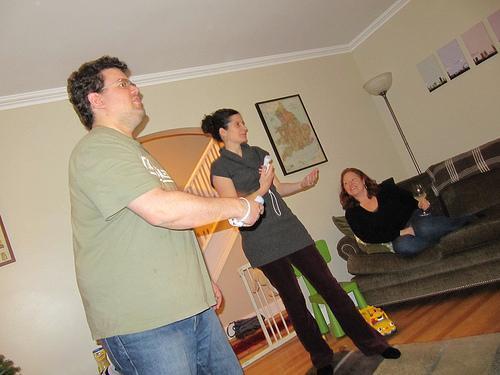How many people are in the picture?
Give a very brief answer. 3. 